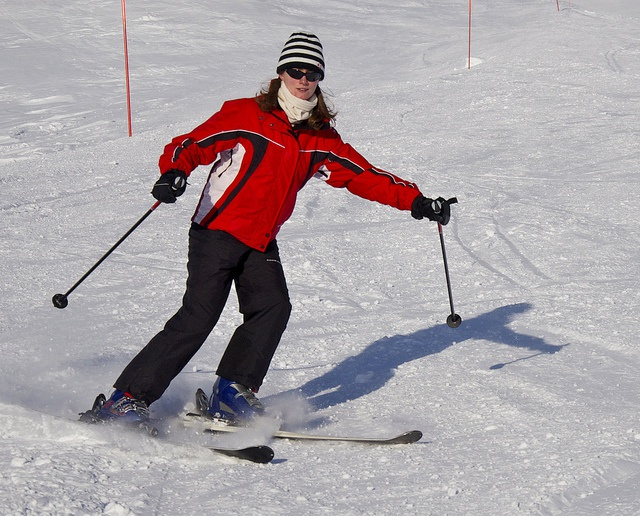Describe the objects in this image and their specific colors. I can see people in darkgray, black, brown, gray, and maroon tones and skis in darkgray, gray, black, and lightgray tones in this image. 